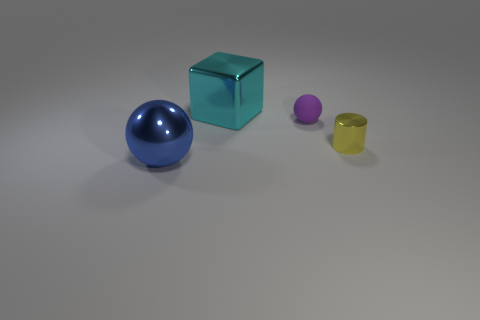Add 1 yellow metallic objects. How many objects exist? 5 Add 2 big gray spheres. How many big gray spheres exist? 2 Subtract 0 purple cylinders. How many objects are left? 4 Subtract all cubes. How many objects are left? 3 Subtract all tiny brown rubber objects. Subtract all yellow objects. How many objects are left? 3 Add 1 small purple rubber objects. How many small purple rubber objects are left? 2 